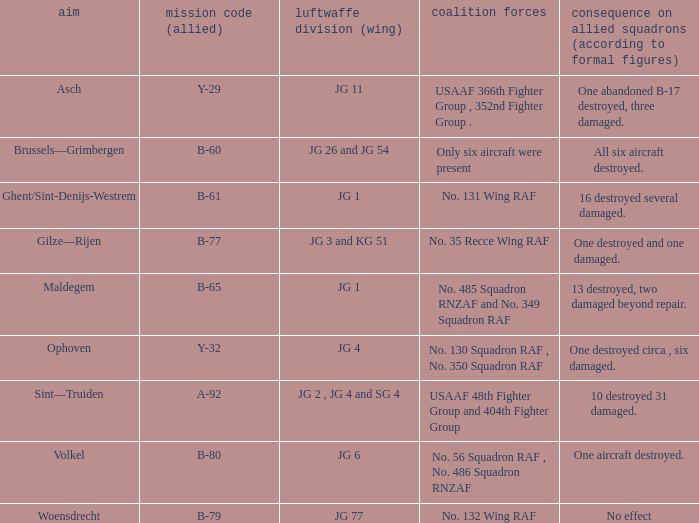What is the allied target code of the group that targetted ghent/sint-denijs-westrem? B-61. 